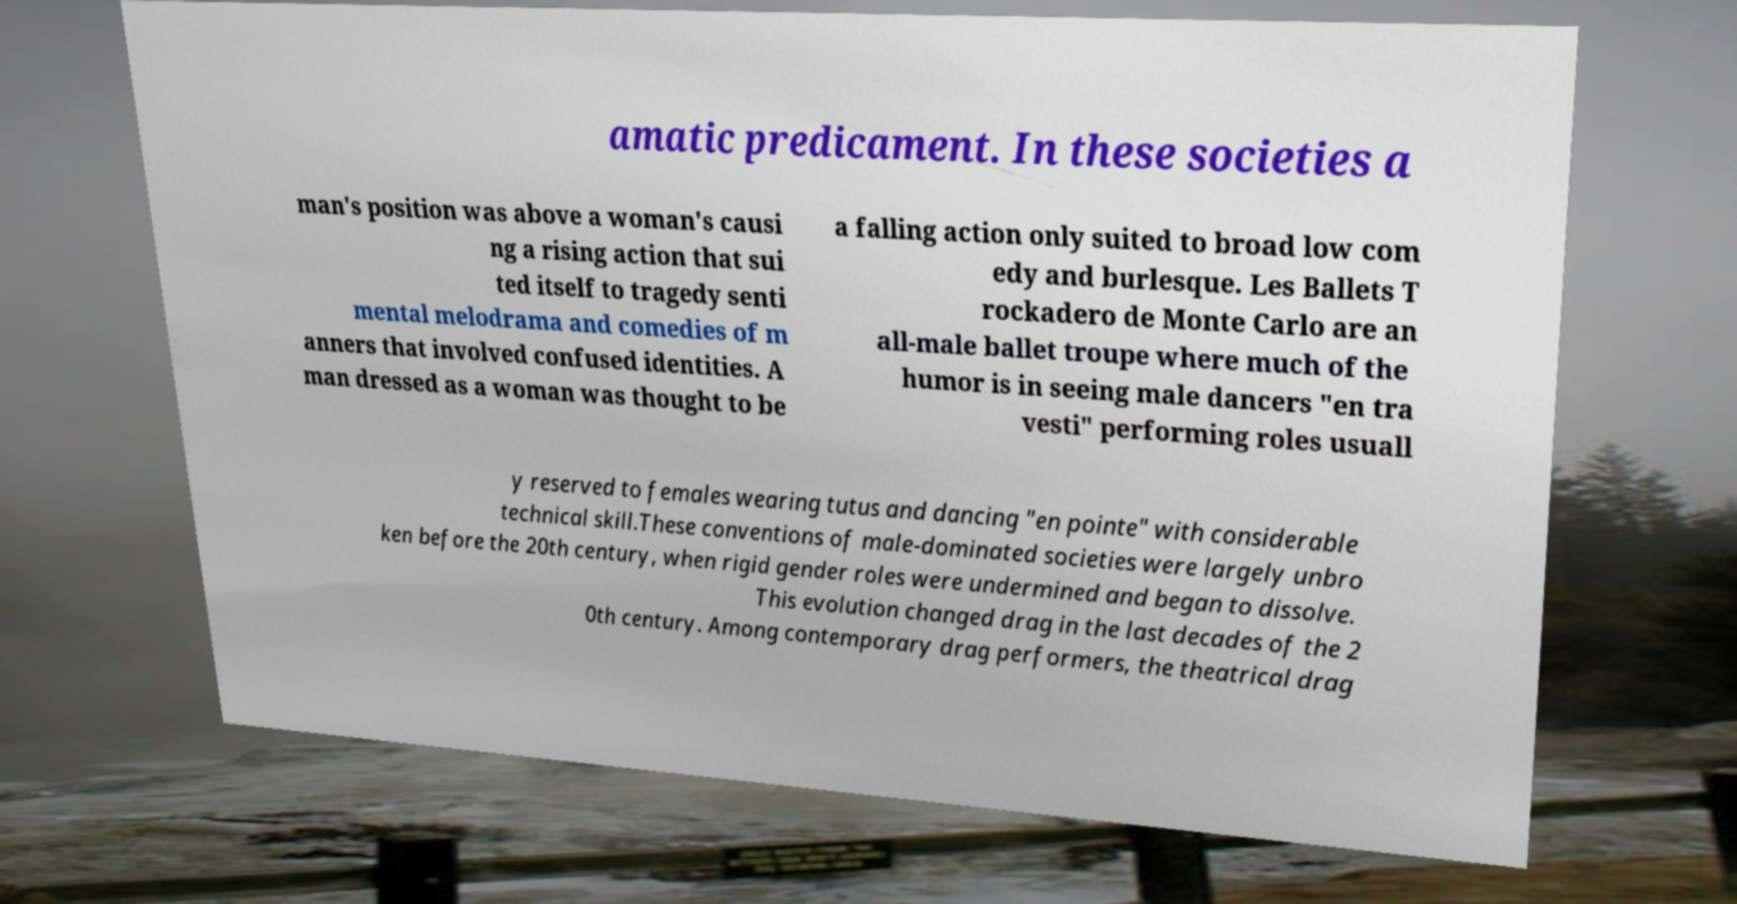Could you assist in decoding the text presented in this image and type it out clearly? amatic predicament. In these societies a man's position was above a woman's causi ng a rising action that sui ted itself to tragedy senti mental melodrama and comedies of m anners that involved confused identities. A man dressed as a woman was thought to be a falling action only suited to broad low com edy and burlesque. Les Ballets T rockadero de Monte Carlo are an all-male ballet troupe where much of the humor is in seeing male dancers "en tra vesti" performing roles usuall y reserved to females wearing tutus and dancing "en pointe" with considerable technical skill.These conventions of male-dominated societies were largely unbro ken before the 20th century, when rigid gender roles were undermined and began to dissolve. This evolution changed drag in the last decades of the 2 0th century. Among contemporary drag performers, the theatrical drag 